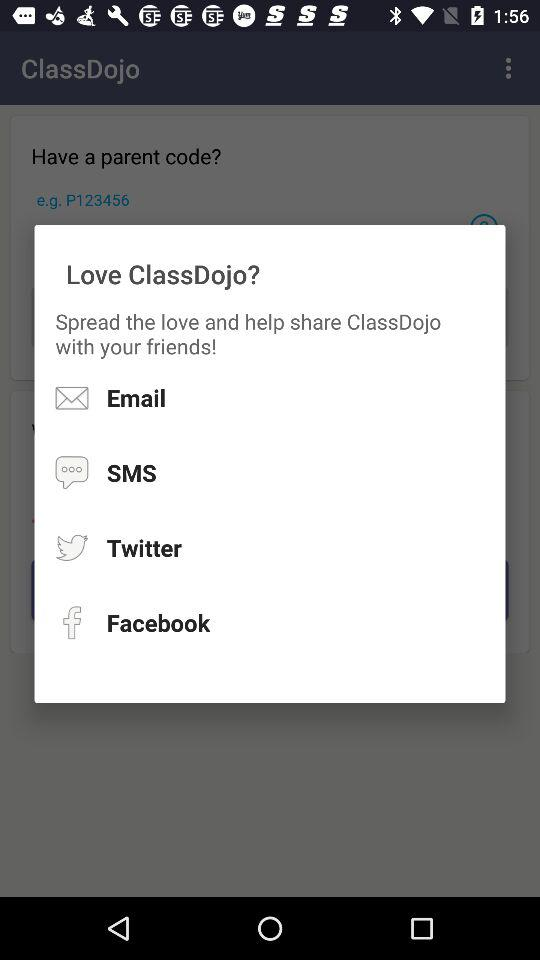What is the example of the parent code? The example of the parent code is "P123456". 